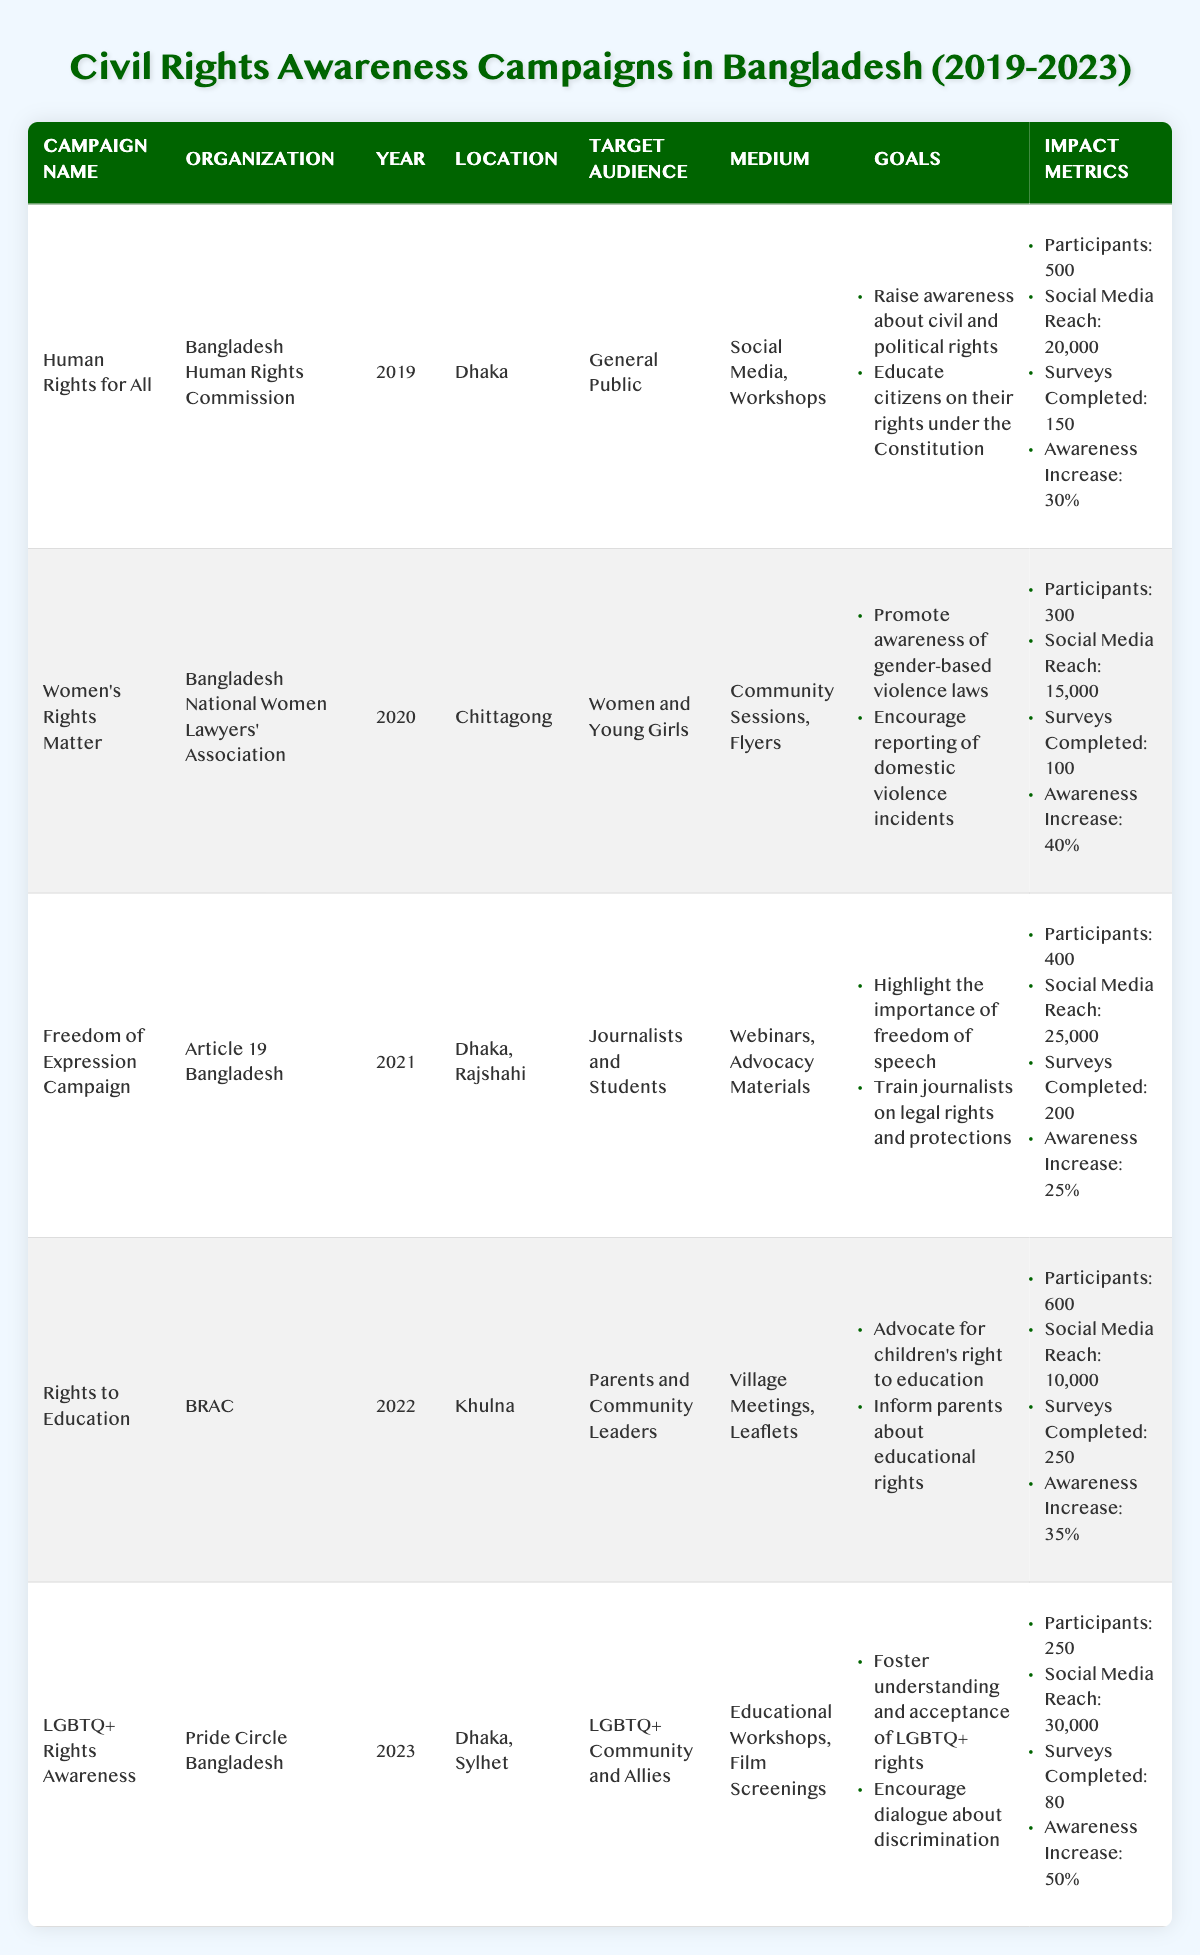What was the primary medium used in the "Rights to Education" campaign? The "Rights to Education" campaign used Village Meetings and Leaflets as its primary medium, as listed in the Medium column of the table.
Answer: Village Meetings, Leaflets In which year was the "Women’s Rights Matter" campaign conducted? The year for the "Women’s Rights Matter" campaign is directly mentioned in the Year column of the table as 2020.
Answer: 2020 Which campaign had the highest social media reach? To find the highest social media reach, we compare the values: 20,000 (Human Rights for All), 15,000 (Women’s Rights Matter), 25,000 (Freedom of Expression Campaign), 10,000 (Rights to Education), and 30,000 (LGBTQ+ Rights Awareness). The maximum is 30,000 from the "LGBTQ+ Rights Awareness" campaign.
Answer: LGBTQ+ Rights Awareness How many surveys were completed for the "Freedom of Expression Campaign"? From the table, the number of completed surveys for the "Freedom of Expression Campaign" is found in the Impact Metrics section, which states 200 surveys were completed.
Answer: 200 Calculate the total number of participants across all campaigns. We need to sum the participants from all campaigns: 500 (Human Rights for All) + 300 (Women’s Rights Matter) + 400 (Freedom of Expression Campaign) + 600 (Rights to Education) + 250 (LGBTQ+ Rights Awareness) = 2050 participants.
Answer: 2050 Did the "LGBTQ+ Rights Awareness" campaign achieve a higher percentage awareness increase than the "Women’s Rights Matter" campaign? The "LGBTQ+ Rights Awareness" campaign had a 50% increase, while the "Women’s Rights Matter" campaign had a 40% increase. Comparing these values confirms that 50% is higher than 40%.
Answer: Yes Which campaign targeted the largest audience based on participant numbers? Checking the participant numbers: 500 (Human Rights for All), 300 (Women’s Rights Matter), 400 (Freedom of Expression Campaign), 600 (Rights to Education), and 250 (LGBTQ+ Rights Awareness), we find that the "Rights to Education" campaign with 600 participants targeted the largest audience.
Answer: Rights to Education What percentage awareness increase was achieved by the "Human Rights for All" campaign? The percentage awareness increase for the "Human Rights for All" campaign is listed as 30% in the Impact Metrics section of the table.
Answer: 30% Identify the organization behind the "Freedom of Expression Campaign". The organization associated with the "Freedom of Expression Campaign" is found in the Organization column of the table, which indicates it was conducted by Article 19 Bangladesh.
Answer: Article 19 Bangladesh Which campaigns involved social media as a medium? By reviewing the Medium column, we see that the "Human Rights for All" and "Freedom of Expression Campaign" both involved social media in their campaigns.
Answer: Human Rights for All, Freedom of Expression Campaign 